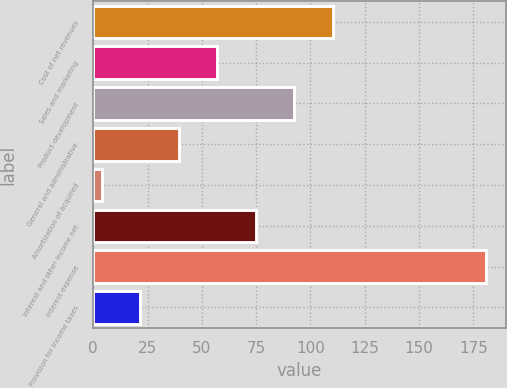<chart> <loc_0><loc_0><loc_500><loc_500><bar_chart><fcel>Cost of net revenues<fcel>Sales and marketing<fcel>Product development<fcel>General and administrative<fcel>Amortization of acquired<fcel>Interest and other income net<fcel>Interest expense<fcel>Provision for income taxes<nl><fcel>110.2<fcel>57.1<fcel>92.5<fcel>39.4<fcel>4<fcel>74.8<fcel>181<fcel>21.7<nl></chart> 